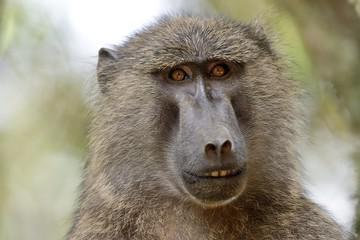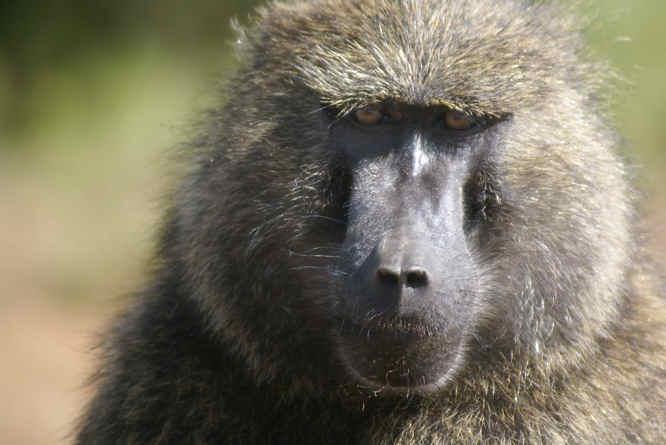The first image is the image on the left, the second image is the image on the right. For the images displayed, is the sentence "One monkey is showing its teeth" factually correct? Answer yes or no. Yes. 